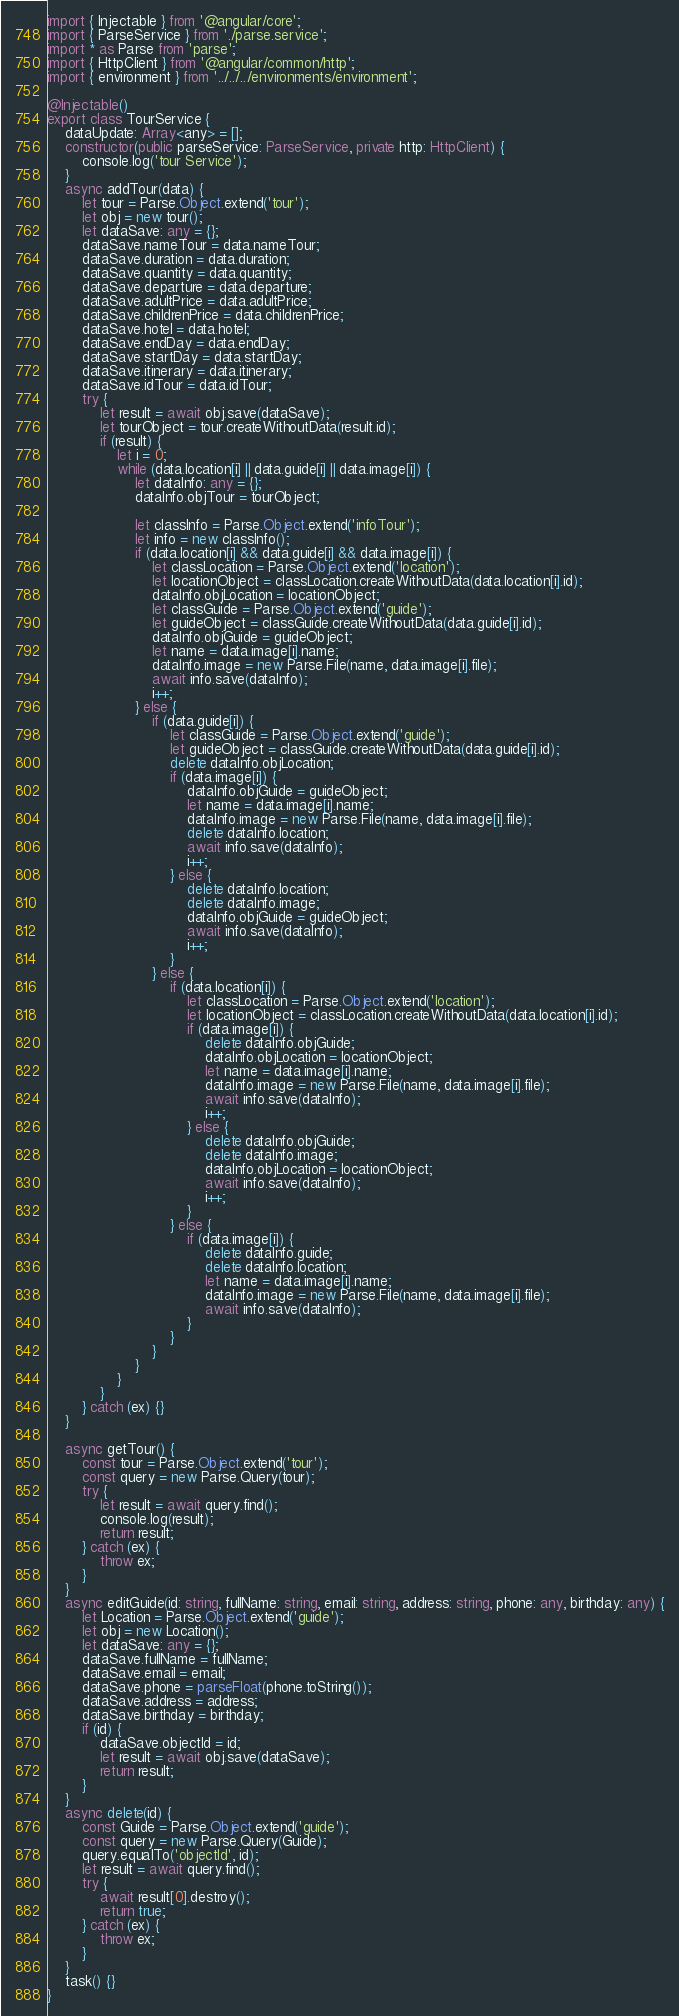Convert code to text. <code><loc_0><loc_0><loc_500><loc_500><_TypeScript_>import { Injectable } from '@angular/core';
import { ParseService } from './parse.service';
import * as Parse from 'parse';
import { HttpClient } from '@angular/common/http';
import { environment } from '../../../environments/environment';

@Injectable()
export class TourService {
    dataUpdate: Array<any> = [];
    constructor(public parseService: ParseService, private http: HttpClient) {
        console.log('tour Service');
    }
    async addTour(data) {
        let tour = Parse.Object.extend('tour');
        let obj = new tour();
        let dataSave: any = {};
        dataSave.nameTour = data.nameTour;
        dataSave.duration = data.duration;
        dataSave.quantity = data.quantity;
        dataSave.departure = data.departure;
        dataSave.adultPrice = data.adultPrice;
        dataSave.childrenPrice = data.childrenPrice;
        dataSave.hotel = data.hotel;
        dataSave.endDay = data.endDay;
        dataSave.startDay = data.startDay;
        dataSave.itinerary = data.itinerary;
        dataSave.idTour = data.idTour;
        try {
            let result = await obj.save(dataSave);
            let tourObject = tour.createWithoutData(result.id);
            if (result) {
                let i = 0;
                while (data.location[i] || data.guide[i] || data.image[i]) {
                    let dataInfo: any = {};
                    dataInfo.objTour = tourObject;

                    let classInfo = Parse.Object.extend('infoTour');
                    let info = new classInfo();
                    if (data.location[i] && data.guide[i] && data.image[i]) {
                        let classLocation = Parse.Object.extend('location');
                        let locationObject = classLocation.createWithoutData(data.location[i].id);
                        dataInfo.objLocation = locationObject;
                        let classGuide = Parse.Object.extend('guide');
                        let guideObject = classGuide.createWithoutData(data.guide[i].id);
                        dataInfo.objGuide = guideObject;
                        let name = data.image[i].name;
                        dataInfo.image = new Parse.File(name, data.image[i].file);
                        await info.save(dataInfo);
                        i++;
                    } else {
                        if (data.guide[i]) {
                            let classGuide = Parse.Object.extend('guide');
                            let guideObject = classGuide.createWithoutData(data.guide[i].id);
                            delete dataInfo.objLocation;
                            if (data.image[i]) {
                                dataInfo.objGuide = guideObject;
                                let name = data.image[i].name;
                                dataInfo.image = new Parse.File(name, data.image[i].file);
                                delete dataInfo.location;
                                await info.save(dataInfo);
                                i++;
                            } else {
                                delete dataInfo.location;
                                delete dataInfo.image;
                                dataInfo.objGuide = guideObject;
                                await info.save(dataInfo);
                                i++;
                            }
                        } else {
                            if (data.location[i]) {
                                let classLocation = Parse.Object.extend('location');
                                let locationObject = classLocation.createWithoutData(data.location[i].id);
                                if (data.image[i]) {
                                    delete dataInfo.objGuide;
                                    dataInfo.objLocation = locationObject;
                                    let name = data.image[i].name;
                                    dataInfo.image = new Parse.File(name, data.image[i].file);
                                    await info.save(dataInfo);
                                    i++;
                                } else {
                                    delete dataInfo.objGuide;
                                    delete dataInfo.image;
                                    dataInfo.objLocation = locationObject;
                                    await info.save(dataInfo);
                                    i++;
                                }
                            } else {
                                if (data.image[i]) {
                                    delete dataInfo.guide;
                                    delete dataInfo.location;
                                    let name = data.image[i].name;
                                    dataInfo.image = new Parse.File(name, data.image[i].file);
                                    await info.save(dataInfo);
                                }
                            }
                        }
                    }
                }
            }
        } catch (ex) {}
    }

    async getTour() {
        const tour = Parse.Object.extend('tour');
        const query = new Parse.Query(tour);
        try {
            let result = await query.find();
            console.log(result);
            return result;
        } catch (ex) {
            throw ex;
        }
    }
    async editGuide(id: string, fullName: string, email: string, address: string, phone: any, birthday: any) {
        let Location = Parse.Object.extend('guide');
        let obj = new Location();
        let dataSave: any = {};
        dataSave.fullName = fullName;
        dataSave.email = email;
        dataSave.phone = parseFloat(phone.toString());
        dataSave.address = address;
        dataSave.birthday = birthday;
        if (id) {
            dataSave.objectId = id;
            let result = await obj.save(dataSave);
            return result;
        }
    }
    async delete(id) {
        const Guide = Parse.Object.extend('guide');
        const query = new Parse.Query(Guide);
        query.equalTo('objectId', id);
        let result = await query.find();
        try {
            await result[0].destroy();
            return true;
        } catch (ex) {
            throw ex;
        }
    }
    task() {}
}
</code> 